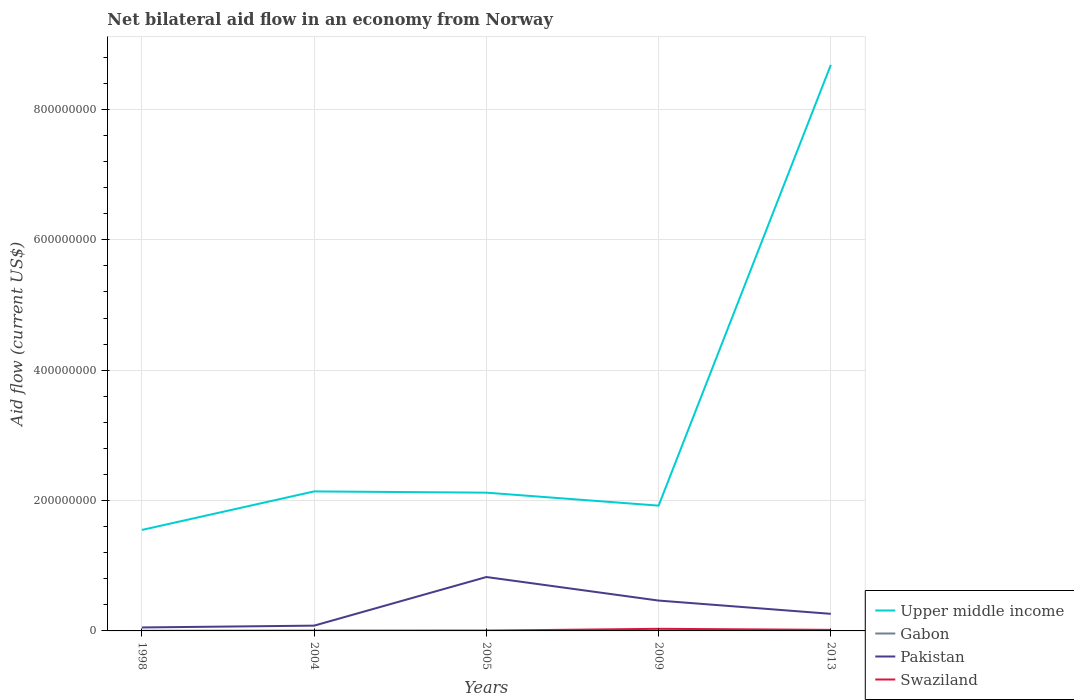How many different coloured lines are there?
Offer a terse response. 4. Does the line corresponding to Pakistan intersect with the line corresponding to Gabon?
Your answer should be very brief. No. Is the number of lines equal to the number of legend labels?
Ensure brevity in your answer.  Yes. Across all years, what is the maximum net bilateral aid flow in Upper middle income?
Offer a terse response. 1.55e+08. What is the total net bilateral aid flow in Swaziland in the graph?
Provide a short and direct response. -2.78e+06. What is the difference between two consecutive major ticks on the Y-axis?
Your answer should be compact. 2.00e+08. Are the values on the major ticks of Y-axis written in scientific E-notation?
Offer a terse response. No. Does the graph contain grids?
Provide a short and direct response. Yes. How many legend labels are there?
Your response must be concise. 4. What is the title of the graph?
Your response must be concise. Net bilateral aid flow in an economy from Norway. What is the Aid flow (current US$) of Upper middle income in 1998?
Provide a succinct answer. 1.55e+08. What is the Aid flow (current US$) of Gabon in 1998?
Provide a short and direct response. 10000. What is the Aid flow (current US$) in Pakistan in 1998?
Your answer should be very brief. 5.33e+06. What is the Aid flow (current US$) in Swaziland in 1998?
Your response must be concise. 7.00e+04. What is the Aid flow (current US$) of Upper middle income in 2004?
Provide a succinct answer. 2.14e+08. What is the Aid flow (current US$) of Gabon in 2004?
Keep it short and to the point. 7.00e+04. What is the Aid flow (current US$) of Pakistan in 2004?
Your answer should be very brief. 8.10e+06. What is the Aid flow (current US$) of Upper middle income in 2005?
Keep it short and to the point. 2.12e+08. What is the Aid flow (current US$) of Gabon in 2005?
Offer a very short reply. 1.70e+05. What is the Aid flow (current US$) of Pakistan in 2005?
Ensure brevity in your answer.  8.27e+07. What is the Aid flow (current US$) of Swaziland in 2005?
Make the answer very short. 4.50e+05. What is the Aid flow (current US$) of Upper middle income in 2009?
Offer a terse response. 1.92e+08. What is the Aid flow (current US$) in Gabon in 2009?
Make the answer very short. 2.00e+04. What is the Aid flow (current US$) in Pakistan in 2009?
Give a very brief answer. 4.66e+07. What is the Aid flow (current US$) of Swaziland in 2009?
Give a very brief answer. 3.23e+06. What is the Aid flow (current US$) of Upper middle income in 2013?
Your answer should be very brief. 8.68e+08. What is the Aid flow (current US$) of Pakistan in 2013?
Provide a succinct answer. 2.62e+07. What is the Aid flow (current US$) of Swaziland in 2013?
Your answer should be very brief. 1.62e+06. Across all years, what is the maximum Aid flow (current US$) in Upper middle income?
Offer a very short reply. 8.68e+08. Across all years, what is the maximum Aid flow (current US$) in Pakistan?
Provide a short and direct response. 8.27e+07. Across all years, what is the maximum Aid flow (current US$) of Swaziland?
Provide a short and direct response. 3.23e+06. Across all years, what is the minimum Aid flow (current US$) of Upper middle income?
Offer a terse response. 1.55e+08. Across all years, what is the minimum Aid flow (current US$) of Pakistan?
Keep it short and to the point. 5.33e+06. Across all years, what is the minimum Aid flow (current US$) of Swaziland?
Your answer should be compact. 7.00e+04. What is the total Aid flow (current US$) in Upper middle income in the graph?
Offer a terse response. 1.64e+09. What is the total Aid flow (current US$) of Gabon in the graph?
Your response must be concise. 3.20e+05. What is the total Aid flow (current US$) in Pakistan in the graph?
Ensure brevity in your answer.  1.69e+08. What is the total Aid flow (current US$) in Swaziland in the graph?
Offer a very short reply. 5.75e+06. What is the difference between the Aid flow (current US$) in Upper middle income in 1998 and that in 2004?
Your answer should be compact. -5.91e+07. What is the difference between the Aid flow (current US$) in Pakistan in 1998 and that in 2004?
Ensure brevity in your answer.  -2.77e+06. What is the difference between the Aid flow (current US$) in Swaziland in 1998 and that in 2004?
Give a very brief answer. -3.10e+05. What is the difference between the Aid flow (current US$) in Upper middle income in 1998 and that in 2005?
Your response must be concise. -5.72e+07. What is the difference between the Aid flow (current US$) in Pakistan in 1998 and that in 2005?
Your response must be concise. -7.74e+07. What is the difference between the Aid flow (current US$) in Swaziland in 1998 and that in 2005?
Ensure brevity in your answer.  -3.80e+05. What is the difference between the Aid flow (current US$) of Upper middle income in 1998 and that in 2009?
Your response must be concise. -3.73e+07. What is the difference between the Aid flow (current US$) of Pakistan in 1998 and that in 2009?
Keep it short and to the point. -4.12e+07. What is the difference between the Aid flow (current US$) of Swaziland in 1998 and that in 2009?
Offer a terse response. -3.16e+06. What is the difference between the Aid flow (current US$) of Upper middle income in 1998 and that in 2013?
Your answer should be compact. -7.13e+08. What is the difference between the Aid flow (current US$) of Gabon in 1998 and that in 2013?
Provide a short and direct response. -4.00e+04. What is the difference between the Aid flow (current US$) of Pakistan in 1998 and that in 2013?
Provide a short and direct response. -2.09e+07. What is the difference between the Aid flow (current US$) in Swaziland in 1998 and that in 2013?
Your answer should be very brief. -1.55e+06. What is the difference between the Aid flow (current US$) in Upper middle income in 2004 and that in 2005?
Keep it short and to the point. 1.93e+06. What is the difference between the Aid flow (current US$) of Gabon in 2004 and that in 2005?
Provide a short and direct response. -1.00e+05. What is the difference between the Aid flow (current US$) of Pakistan in 2004 and that in 2005?
Provide a succinct answer. -7.46e+07. What is the difference between the Aid flow (current US$) of Swaziland in 2004 and that in 2005?
Keep it short and to the point. -7.00e+04. What is the difference between the Aid flow (current US$) of Upper middle income in 2004 and that in 2009?
Keep it short and to the point. 2.18e+07. What is the difference between the Aid flow (current US$) in Gabon in 2004 and that in 2009?
Your answer should be compact. 5.00e+04. What is the difference between the Aid flow (current US$) in Pakistan in 2004 and that in 2009?
Provide a short and direct response. -3.85e+07. What is the difference between the Aid flow (current US$) in Swaziland in 2004 and that in 2009?
Give a very brief answer. -2.85e+06. What is the difference between the Aid flow (current US$) in Upper middle income in 2004 and that in 2013?
Offer a terse response. -6.54e+08. What is the difference between the Aid flow (current US$) of Pakistan in 2004 and that in 2013?
Offer a very short reply. -1.81e+07. What is the difference between the Aid flow (current US$) in Swaziland in 2004 and that in 2013?
Your answer should be compact. -1.24e+06. What is the difference between the Aid flow (current US$) in Upper middle income in 2005 and that in 2009?
Give a very brief answer. 1.99e+07. What is the difference between the Aid flow (current US$) in Gabon in 2005 and that in 2009?
Your response must be concise. 1.50e+05. What is the difference between the Aid flow (current US$) in Pakistan in 2005 and that in 2009?
Offer a terse response. 3.61e+07. What is the difference between the Aid flow (current US$) of Swaziland in 2005 and that in 2009?
Give a very brief answer. -2.78e+06. What is the difference between the Aid flow (current US$) in Upper middle income in 2005 and that in 2013?
Provide a succinct answer. -6.56e+08. What is the difference between the Aid flow (current US$) in Pakistan in 2005 and that in 2013?
Provide a short and direct response. 5.65e+07. What is the difference between the Aid flow (current US$) in Swaziland in 2005 and that in 2013?
Your answer should be very brief. -1.17e+06. What is the difference between the Aid flow (current US$) of Upper middle income in 2009 and that in 2013?
Your answer should be compact. -6.76e+08. What is the difference between the Aid flow (current US$) of Pakistan in 2009 and that in 2013?
Offer a terse response. 2.04e+07. What is the difference between the Aid flow (current US$) in Swaziland in 2009 and that in 2013?
Keep it short and to the point. 1.61e+06. What is the difference between the Aid flow (current US$) of Upper middle income in 1998 and the Aid flow (current US$) of Gabon in 2004?
Make the answer very short. 1.55e+08. What is the difference between the Aid flow (current US$) of Upper middle income in 1998 and the Aid flow (current US$) of Pakistan in 2004?
Offer a terse response. 1.47e+08. What is the difference between the Aid flow (current US$) in Upper middle income in 1998 and the Aid flow (current US$) in Swaziland in 2004?
Your answer should be very brief. 1.55e+08. What is the difference between the Aid flow (current US$) in Gabon in 1998 and the Aid flow (current US$) in Pakistan in 2004?
Make the answer very short. -8.09e+06. What is the difference between the Aid flow (current US$) in Gabon in 1998 and the Aid flow (current US$) in Swaziland in 2004?
Offer a very short reply. -3.70e+05. What is the difference between the Aid flow (current US$) in Pakistan in 1998 and the Aid flow (current US$) in Swaziland in 2004?
Your response must be concise. 4.95e+06. What is the difference between the Aid flow (current US$) in Upper middle income in 1998 and the Aid flow (current US$) in Gabon in 2005?
Provide a succinct answer. 1.55e+08. What is the difference between the Aid flow (current US$) in Upper middle income in 1998 and the Aid flow (current US$) in Pakistan in 2005?
Give a very brief answer. 7.23e+07. What is the difference between the Aid flow (current US$) in Upper middle income in 1998 and the Aid flow (current US$) in Swaziland in 2005?
Provide a short and direct response. 1.54e+08. What is the difference between the Aid flow (current US$) of Gabon in 1998 and the Aid flow (current US$) of Pakistan in 2005?
Offer a very short reply. -8.27e+07. What is the difference between the Aid flow (current US$) in Gabon in 1998 and the Aid flow (current US$) in Swaziland in 2005?
Offer a terse response. -4.40e+05. What is the difference between the Aid flow (current US$) in Pakistan in 1998 and the Aid flow (current US$) in Swaziland in 2005?
Keep it short and to the point. 4.88e+06. What is the difference between the Aid flow (current US$) in Upper middle income in 1998 and the Aid flow (current US$) in Gabon in 2009?
Your response must be concise. 1.55e+08. What is the difference between the Aid flow (current US$) in Upper middle income in 1998 and the Aid flow (current US$) in Pakistan in 2009?
Make the answer very short. 1.08e+08. What is the difference between the Aid flow (current US$) of Upper middle income in 1998 and the Aid flow (current US$) of Swaziland in 2009?
Ensure brevity in your answer.  1.52e+08. What is the difference between the Aid flow (current US$) in Gabon in 1998 and the Aid flow (current US$) in Pakistan in 2009?
Offer a terse response. -4.66e+07. What is the difference between the Aid flow (current US$) of Gabon in 1998 and the Aid flow (current US$) of Swaziland in 2009?
Keep it short and to the point. -3.22e+06. What is the difference between the Aid flow (current US$) of Pakistan in 1998 and the Aid flow (current US$) of Swaziland in 2009?
Give a very brief answer. 2.10e+06. What is the difference between the Aid flow (current US$) of Upper middle income in 1998 and the Aid flow (current US$) of Gabon in 2013?
Keep it short and to the point. 1.55e+08. What is the difference between the Aid flow (current US$) of Upper middle income in 1998 and the Aid flow (current US$) of Pakistan in 2013?
Your response must be concise. 1.29e+08. What is the difference between the Aid flow (current US$) of Upper middle income in 1998 and the Aid flow (current US$) of Swaziland in 2013?
Your response must be concise. 1.53e+08. What is the difference between the Aid flow (current US$) in Gabon in 1998 and the Aid flow (current US$) in Pakistan in 2013?
Give a very brief answer. -2.62e+07. What is the difference between the Aid flow (current US$) of Gabon in 1998 and the Aid flow (current US$) of Swaziland in 2013?
Your answer should be very brief. -1.61e+06. What is the difference between the Aid flow (current US$) of Pakistan in 1998 and the Aid flow (current US$) of Swaziland in 2013?
Ensure brevity in your answer.  3.71e+06. What is the difference between the Aid flow (current US$) of Upper middle income in 2004 and the Aid flow (current US$) of Gabon in 2005?
Keep it short and to the point. 2.14e+08. What is the difference between the Aid flow (current US$) of Upper middle income in 2004 and the Aid flow (current US$) of Pakistan in 2005?
Make the answer very short. 1.31e+08. What is the difference between the Aid flow (current US$) in Upper middle income in 2004 and the Aid flow (current US$) in Swaziland in 2005?
Give a very brief answer. 2.14e+08. What is the difference between the Aid flow (current US$) of Gabon in 2004 and the Aid flow (current US$) of Pakistan in 2005?
Keep it short and to the point. -8.26e+07. What is the difference between the Aid flow (current US$) of Gabon in 2004 and the Aid flow (current US$) of Swaziland in 2005?
Provide a short and direct response. -3.80e+05. What is the difference between the Aid flow (current US$) in Pakistan in 2004 and the Aid flow (current US$) in Swaziland in 2005?
Keep it short and to the point. 7.65e+06. What is the difference between the Aid flow (current US$) in Upper middle income in 2004 and the Aid flow (current US$) in Gabon in 2009?
Your response must be concise. 2.14e+08. What is the difference between the Aid flow (current US$) in Upper middle income in 2004 and the Aid flow (current US$) in Pakistan in 2009?
Provide a succinct answer. 1.67e+08. What is the difference between the Aid flow (current US$) of Upper middle income in 2004 and the Aid flow (current US$) of Swaziland in 2009?
Your answer should be very brief. 2.11e+08. What is the difference between the Aid flow (current US$) of Gabon in 2004 and the Aid flow (current US$) of Pakistan in 2009?
Your answer should be compact. -4.65e+07. What is the difference between the Aid flow (current US$) in Gabon in 2004 and the Aid flow (current US$) in Swaziland in 2009?
Offer a terse response. -3.16e+06. What is the difference between the Aid flow (current US$) of Pakistan in 2004 and the Aid flow (current US$) of Swaziland in 2009?
Provide a succinct answer. 4.87e+06. What is the difference between the Aid flow (current US$) in Upper middle income in 2004 and the Aid flow (current US$) in Gabon in 2013?
Offer a very short reply. 2.14e+08. What is the difference between the Aid flow (current US$) in Upper middle income in 2004 and the Aid flow (current US$) in Pakistan in 2013?
Keep it short and to the point. 1.88e+08. What is the difference between the Aid flow (current US$) of Upper middle income in 2004 and the Aid flow (current US$) of Swaziland in 2013?
Give a very brief answer. 2.12e+08. What is the difference between the Aid flow (current US$) in Gabon in 2004 and the Aid flow (current US$) in Pakistan in 2013?
Provide a succinct answer. -2.61e+07. What is the difference between the Aid flow (current US$) of Gabon in 2004 and the Aid flow (current US$) of Swaziland in 2013?
Provide a succinct answer. -1.55e+06. What is the difference between the Aid flow (current US$) of Pakistan in 2004 and the Aid flow (current US$) of Swaziland in 2013?
Offer a very short reply. 6.48e+06. What is the difference between the Aid flow (current US$) of Upper middle income in 2005 and the Aid flow (current US$) of Gabon in 2009?
Provide a succinct answer. 2.12e+08. What is the difference between the Aid flow (current US$) in Upper middle income in 2005 and the Aid flow (current US$) in Pakistan in 2009?
Provide a short and direct response. 1.66e+08. What is the difference between the Aid flow (current US$) in Upper middle income in 2005 and the Aid flow (current US$) in Swaziland in 2009?
Offer a terse response. 2.09e+08. What is the difference between the Aid flow (current US$) in Gabon in 2005 and the Aid flow (current US$) in Pakistan in 2009?
Make the answer very short. -4.64e+07. What is the difference between the Aid flow (current US$) of Gabon in 2005 and the Aid flow (current US$) of Swaziland in 2009?
Ensure brevity in your answer.  -3.06e+06. What is the difference between the Aid flow (current US$) of Pakistan in 2005 and the Aid flow (current US$) of Swaziland in 2009?
Ensure brevity in your answer.  7.94e+07. What is the difference between the Aid flow (current US$) in Upper middle income in 2005 and the Aid flow (current US$) in Gabon in 2013?
Provide a short and direct response. 2.12e+08. What is the difference between the Aid flow (current US$) in Upper middle income in 2005 and the Aid flow (current US$) in Pakistan in 2013?
Offer a terse response. 1.86e+08. What is the difference between the Aid flow (current US$) in Upper middle income in 2005 and the Aid flow (current US$) in Swaziland in 2013?
Your answer should be very brief. 2.10e+08. What is the difference between the Aid flow (current US$) in Gabon in 2005 and the Aid flow (current US$) in Pakistan in 2013?
Your answer should be very brief. -2.60e+07. What is the difference between the Aid flow (current US$) in Gabon in 2005 and the Aid flow (current US$) in Swaziland in 2013?
Provide a succinct answer. -1.45e+06. What is the difference between the Aid flow (current US$) of Pakistan in 2005 and the Aid flow (current US$) of Swaziland in 2013?
Your answer should be compact. 8.11e+07. What is the difference between the Aid flow (current US$) in Upper middle income in 2009 and the Aid flow (current US$) in Gabon in 2013?
Your response must be concise. 1.92e+08. What is the difference between the Aid flow (current US$) of Upper middle income in 2009 and the Aid flow (current US$) of Pakistan in 2013?
Your response must be concise. 1.66e+08. What is the difference between the Aid flow (current US$) in Upper middle income in 2009 and the Aid flow (current US$) in Swaziland in 2013?
Give a very brief answer. 1.91e+08. What is the difference between the Aid flow (current US$) of Gabon in 2009 and the Aid flow (current US$) of Pakistan in 2013?
Offer a terse response. -2.62e+07. What is the difference between the Aid flow (current US$) of Gabon in 2009 and the Aid flow (current US$) of Swaziland in 2013?
Ensure brevity in your answer.  -1.60e+06. What is the difference between the Aid flow (current US$) in Pakistan in 2009 and the Aid flow (current US$) in Swaziland in 2013?
Your response must be concise. 4.50e+07. What is the average Aid flow (current US$) in Upper middle income per year?
Provide a short and direct response. 3.28e+08. What is the average Aid flow (current US$) of Gabon per year?
Your answer should be very brief. 6.40e+04. What is the average Aid flow (current US$) in Pakistan per year?
Keep it short and to the point. 3.38e+07. What is the average Aid flow (current US$) in Swaziland per year?
Provide a succinct answer. 1.15e+06. In the year 1998, what is the difference between the Aid flow (current US$) in Upper middle income and Aid flow (current US$) in Gabon?
Your answer should be compact. 1.55e+08. In the year 1998, what is the difference between the Aid flow (current US$) of Upper middle income and Aid flow (current US$) of Pakistan?
Your answer should be compact. 1.50e+08. In the year 1998, what is the difference between the Aid flow (current US$) in Upper middle income and Aid flow (current US$) in Swaziland?
Offer a terse response. 1.55e+08. In the year 1998, what is the difference between the Aid flow (current US$) in Gabon and Aid flow (current US$) in Pakistan?
Offer a terse response. -5.32e+06. In the year 1998, what is the difference between the Aid flow (current US$) of Gabon and Aid flow (current US$) of Swaziland?
Offer a very short reply. -6.00e+04. In the year 1998, what is the difference between the Aid flow (current US$) of Pakistan and Aid flow (current US$) of Swaziland?
Offer a very short reply. 5.26e+06. In the year 2004, what is the difference between the Aid flow (current US$) in Upper middle income and Aid flow (current US$) in Gabon?
Offer a terse response. 2.14e+08. In the year 2004, what is the difference between the Aid flow (current US$) in Upper middle income and Aid flow (current US$) in Pakistan?
Provide a succinct answer. 2.06e+08. In the year 2004, what is the difference between the Aid flow (current US$) in Upper middle income and Aid flow (current US$) in Swaziland?
Offer a terse response. 2.14e+08. In the year 2004, what is the difference between the Aid flow (current US$) in Gabon and Aid flow (current US$) in Pakistan?
Offer a terse response. -8.03e+06. In the year 2004, what is the difference between the Aid flow (current US$) of Gabon and Aid flow (current US$) of Swaziland?
Your answer should be very brief. -3.10e+05. In the year 2004, what is the difference between the Aid flow (current US$) of Pakistan and Aid flow (current US$) of Swaziland?
Ensure brevity in your answer.  7.72e+06. In the year 2005, what is the difference between the Aid flow (current US$) of Upper middle income and Aid flow (current US$) of Gabon?
Provide a short and direct response. 2.12e+08. In the year 2005, what is the difference between the Aid flow (current US$) in Upper middle income and Aid flow (current US$) in Pakistan?
Keep it short and to the point. 1.29e+08. In the year 2005, what is the difference between the Aid flow (current US$) in Upper middle income and Aid flow (current US$) in Swaziland?
Make the answer very short. 2.12e+08. In the year 2005, what is the difference between the Aid flow (current US$) of Gabon and Aid flow (current US$) of Pakistan?
Provide a short and direct response. -8.25e+07. In the year 2005, what is the difference between the Aid flow (current US$) in Gabon and Aid flow (current US$) in Swaziland?
Make the answer very short. -2.80e+05. In the year 2005, what is the difference between the Aid flow (current US$) of Pakistan and Aid flow (current US$) of Swaziland?
Make the answer very short. 8.22e+07. In the year 2009, what is the difference between the Aid flow (current US$) of Upper middle income and Aid flow (current US$) of Gabon?
Your response must be concise. 1.92e+08. In the year 2009, what is the difference between the Aid flow (current US$) in Upper middle income and Aid flow (current US$) in Pakistan?
Give a very brief answer. 1.46e+08. In the year 2009, what is the difference between the Aid flow (current US$) in Upper middle income and Aid flow (current US$) in Swaziland?
Offer a terse response. 1.89e+08. In the year 2009, what is the difference between the Aid flow (current US$) in Gabon and Aid flow (current US$) in Pakistan?
Keep it short and to the point. -4.66e+07. In the year 2009, what is the difference between the Aid flow (current US$) in Gabon and Aid flow (current US$) in Swaziland?
Provide a succinct answer. -3.21e+06. In the year 2009, what is the difference between the Aid flow (current US$) in Pakistan and Aid flow (current US$) in Swaziland?
Keep it short and to the point. 4.33e+07. In the year 2013, what is the difference between the Aid flow (current US$) of Upper middle income and Aid flow (current US$) of Gabon?
Offer a terse response. 8.68e+08. In the year 2013, what is the difference between the Aid flow (current US$) of Upper middle income and Aid flow (current US$) of Pakistan?
Give a very brief answer. 8.42e+08. In the year 2013, what is the difference between the Aid flow (current US$) of Upper middle income and Aid flow (current US$) of Swaziland?
Ensure brevity in your answer.  8.67e+08. In the year 2013, what is the difference between the Aid flow (current US$) in Gabon and Aid flow (current US$) in Pakistan?
Ensure brevity in your answer.  -2.62e+07. In the year 2013, what is the difference between the Aid flow (current US$) in Gabon and Aid flow (current US$) in Swaziland?
Your response must be concise. -1.57e+06. In the year 2013, what is the difference between the Aid flow (current US$) of Pakistan and Aid flow (current US$) of Swaziland?
Your answer should be very brief. 2.46e+07. What is the ratio of the Aid flow (current US$) in Upper middle income in 1998 to that in 2004?
Your answer should be very brief. 0.72. What is the ratio of the Aid flow (current US$) in Gabon in 1998 to that in 2004?
Make the answer very short. 0.14. What is the ratio of the Aid flow (current US$) in Pakistan in 1998 to that in 2004?
Provide a short and direct response. 0.66. What is the ratio of the Aid flow (current US$) in Swaziland in 1998 to that in 2004?
Offer a terse response. 0.18. What is the ratio of the Aid flow (current US$) of Upper middle income in 1998 to that in 2005?
Your answer should be very brief. 0.73. What is the ratio of the Aid flow (current US$) in Gabon in 1998 to that in 2005?
Ensure brevity in your answer.  0.06. What is the ratio of the Aid flow (current US$) of Pakistan in 1998 to that in 2005?
Offer a very short reply. 0.06. What is the ratio of the Aid flow (current US$) in Swaziland in 1998 to that in 2005?
Offer a terse response. 0.16. What is the ratio of the Aid flow (current US$) of Upper middle income in 1998 to that in 2009?
Provide a succinct answer. 0.81. What is the ratio of the Aid flow (current US$) of Pakistan in 1998 to that in 2009?
Your answer should be compact. 0.11. What is the ratio of the Aid flow (current US$) of Swaziland in 1998 to that in 2009?
Ensure brevity in your answer.  0.02. What is the ratio of the Aid flow (current US$) in Upper middle income in 1998 to that in 2013?
Keep it short and to the point. 0.18. What is the ratio of the Aid flow (current US$) in Gabon in 1998 to that in 2013?
Your response must be concise. 0.2. What is the ratio of the Aid flow (current US$) of Pakistan in 1998 to that in 2013?
Make the answer very short. 0.2. What is the ratio of the Aid flow (current US$) of Swaziland in 1998 to that in 2013?
Provide a short and direct response. 0.04. What is the ratio of the Aid flow (current US$) in Upper middle income in 2004 to that in 2005?
Give a very brief answer. 1.01. What is the ratio of the Aid flow (current US$) of Gabon in 2004 to that in 2005?
Your answer should be compact. 0.41. What is the ratio of the Aid flow (current US$) of Pakistan in 2004 to that in 2005?
Your response must be concise. 0.1. What is the ratio of the Aid flow (current US$) of Swaziland in 2004 to that in 2005?
Your response must be concise. 0.84. What is the ratio of the Aid flow (current US$) in Upper middle income in 2004 to that in 2009?
Offer a very short reply. 1.11. What is the ratio of the Aid flow (current US$) in Pakistan in 2004 to that in 2009?
Provide a succinct answer. 0.17. What is the ratio of the Aid flow (current US$) of Swaziland in 2004 to that in 2009?
Your answer should be compact. 0.12. What is the ratio of the Aid flow (current US$) of Upper middle income in 2004 to that in 2013?
Your answer should be compact. 0.25. What is the ratio of the Aid flow (current US$) in Pakistan in 2004 to that in 2013?
Your answer should be compact. 0.31. What is the ratio of the Aid flow (current US$) in Swaziland in 2004 to that in 2013?
Give a very brief answer. 0.23. What is the ratio of the Aid flow (current US$) in Upper middle income in 2005 to that in 2009?
Make the answer very short. 1.1. What is the ratio of the Aid flow (current US$) in Gabon in 2005 to that in 2009?
Provide a succinct answer. 8.5. What is the ratio of the Aid flow (current US$) of Pakistan in 2005 to that in 2009?
Keep it short and to the point. 1.78. What is the ratio of the Aid flow (current US$) in Swaziland in 2005 to that in 2009?
Your answer should be very brief. 0.14. What is the ratio of the Aid flow (current US$) of Upper middle income in 2005 to that in 2013?
Your answer should be compact. 0.24. What is the ratio of the Aid flow (current US$) of Pakistan in 2005 to that in 2013?
Your answer should be compact. 3.15. What is the ratio of the Aid flow (current US$) in Swaziland in 2005 to that in 2013?
Ensure brevity in your answer.  0.28. What is the ratio of the Aid flow (current US$) in Upper middle income in 2009 to that in 2013?
Your answer should be compact. 0.22. What is the ratio of the Aid flow (current US$) of Gabon in 2009 to that in 2013?
Provide a succinct answer. 0.4. What is the ratio of the Aid flow (current US$) in Pakistan in 2009 to that in 2013?
Provide a short and direct response. 1.78. What is the ratio of the Aid flow (current US$) of Swaziland in 2009 to that in 2013?
Your answer should be very brief. 1.99. What is the difference between the highest and the second highest Aid flow (current US$) of Upper middle income?
Provide a short and direct response. 6.54e+08. What is the difference between the highest and the second highest Aid flow (current US$) in Pakistan?
Ensure brevity in your answer.  3.61e+07. What is the difference between the highest and the second highest Aid flow (current US$) of Swaziland?
Your answer should be very brief. 1.61e+06. What is the difference between the highest and the lowest Aid flow (current US$) in Upper middle income?
Provide a short and direct response. 7.13e+08. What is the difference between the highest and the lowest Aid flow (current US$) in Pakistan?
Make the answer very short. 7.74e+07. What is the difference between the highest and the lowest Aid flow (current US$) in Swaziland?
Your answer should be compact. 3.16e+06. 